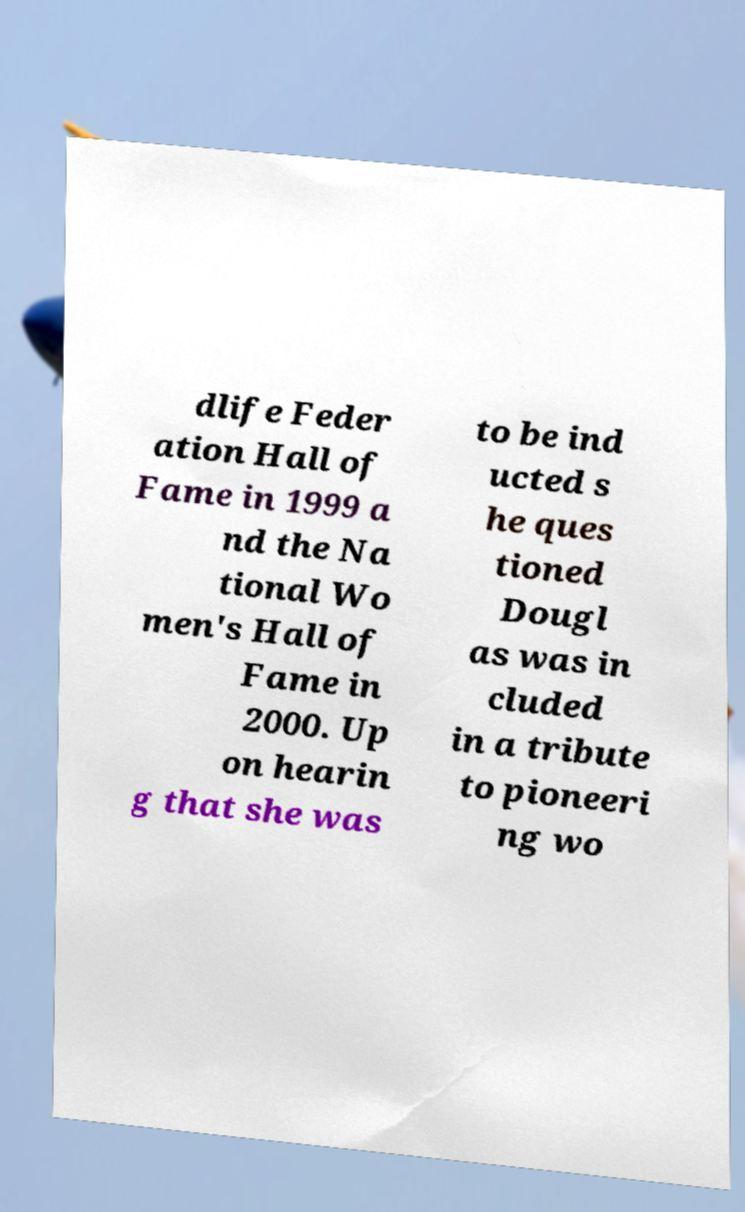For documentation purposes, I need the text within this image transcribed. Could you provide that? dlife Feder ation Hall of Fame in 1999 a nd the Na tional Wo men's Hall of Fame in 2000. Up on hearin g that she was to be ind ucted s he ques tioned Dougl as was in cluded in a tribute to pioneeri ng wo 